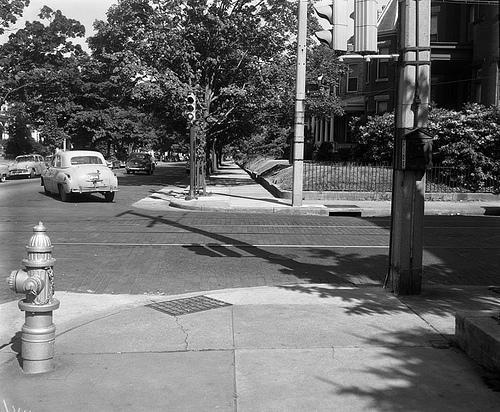How many cars can you see?
Give a very brief answer. 1. 